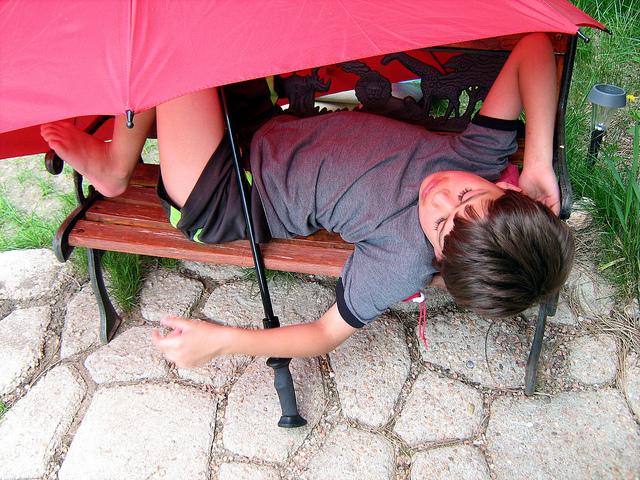Is this boy asleep?
Write a very short answer. Yes. Does the boy fit on the bench?
Quick response, please. No. What is this person showing?
Short answer required. Umbrella. 